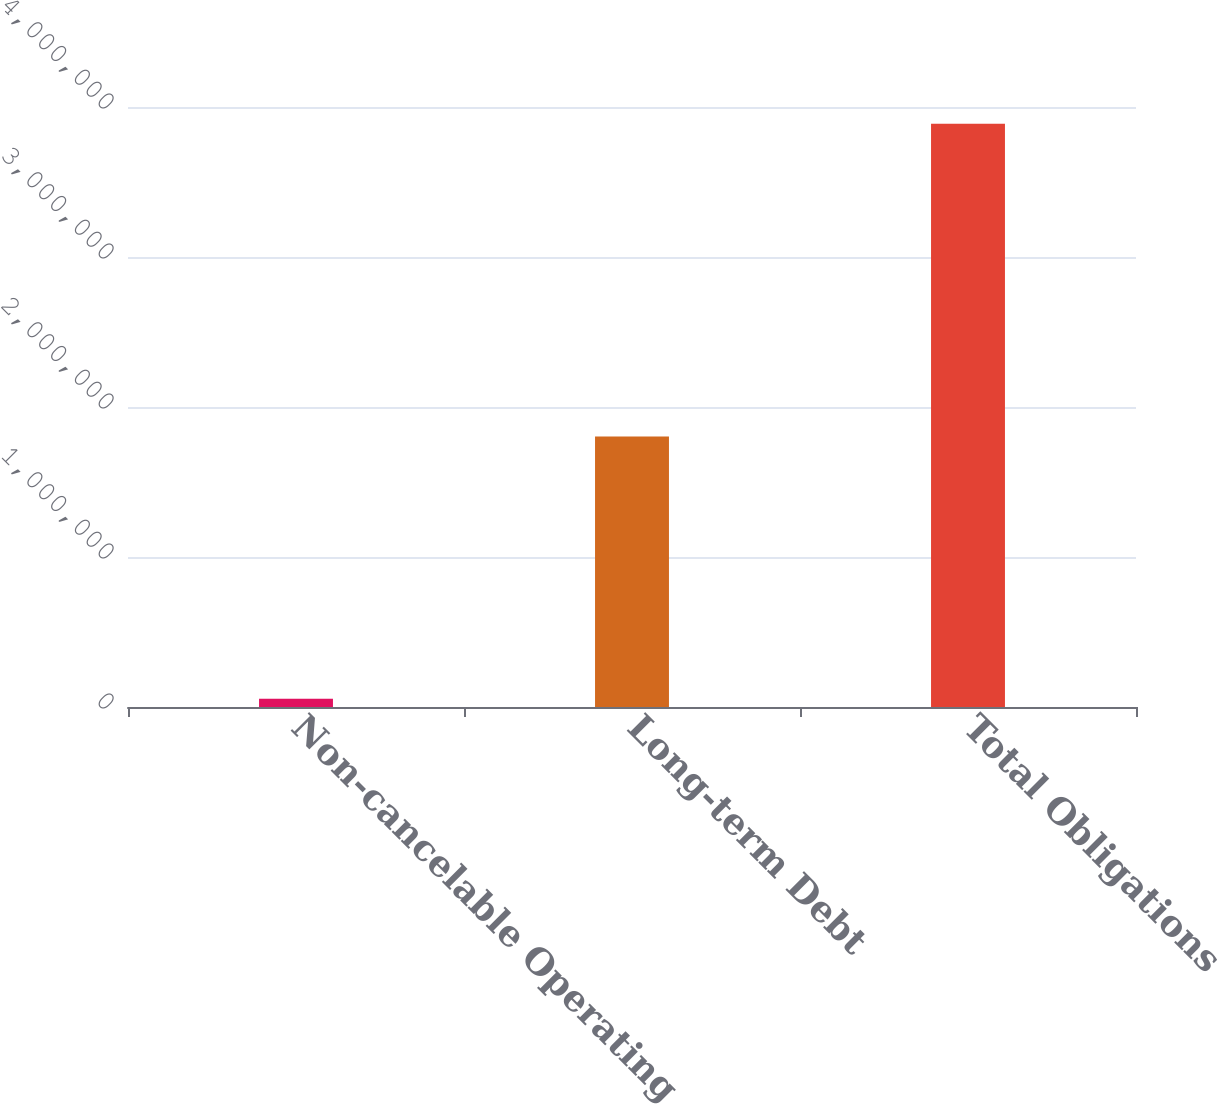Convert chart to OTSL. <chart><loc_0><loc_0><loc_500><loc_500><bar_chart><fcel>Non-cancelable Operating<fcel>Long-term Debt<fcel>Total Obligations<nl><fcel>55580<fcel>1.80322e+06<fcel>3.8885e+06<nl></chart> 